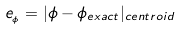Convert formula to latex. <formula><loc_0><loc_0><loc_500><loc_500>e _ { _ { \phi } } = | \phi - \phi _ { e x a c t } | _ { c e n t r o i d }</formula> 